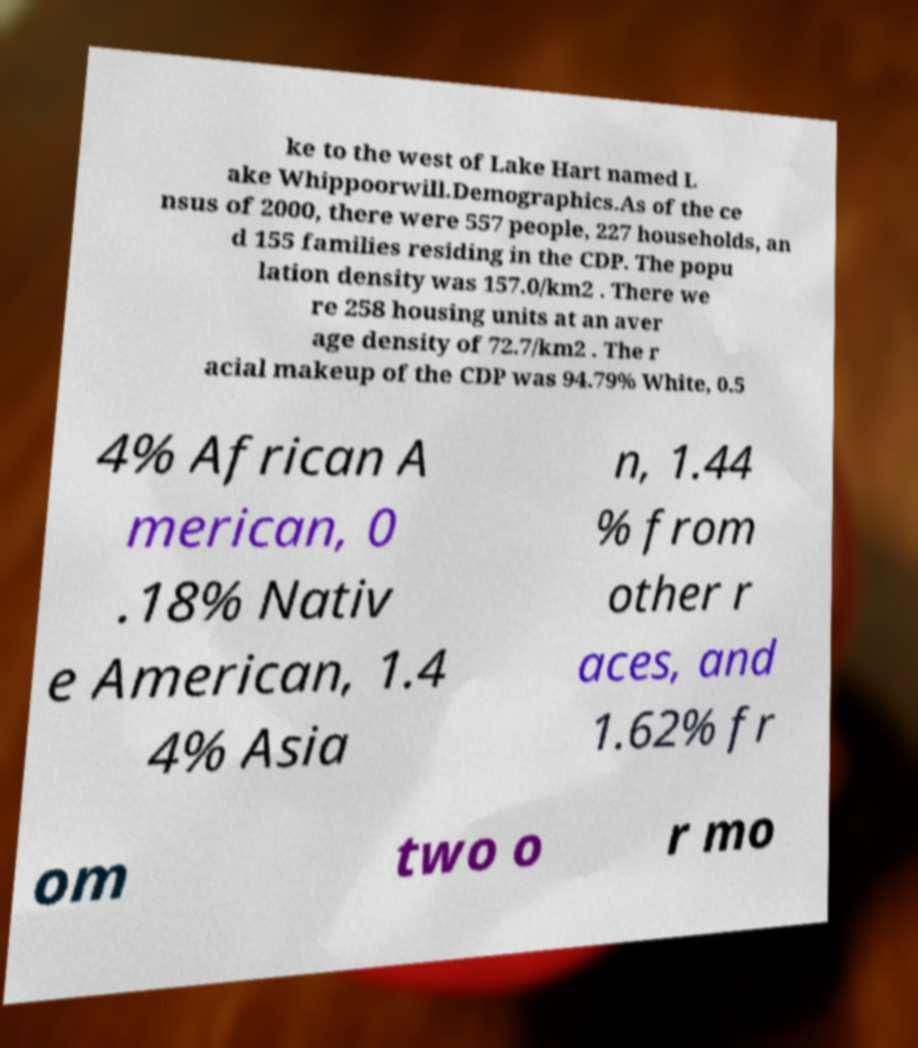Can you accurately transcribe the text from the provided image for me? ke to the west of Lake Hart named L ake Whippoorwill.Demographics.As of the ce nsus of 2000, there were 557 people, 227 households, an d 155 families residing in the CDP. The popu lation density was 157.0/km2 . There we re 258 housing units at an aver age density of 72.7/km2 . The r acial makeup of the CDP was 94.79% White, 0.5 4% African A merican, 0 .18% Nativ e American, 1.4 4% Asia n, 1.44 % from other r aces, and 1.62% fr om two o r mo 